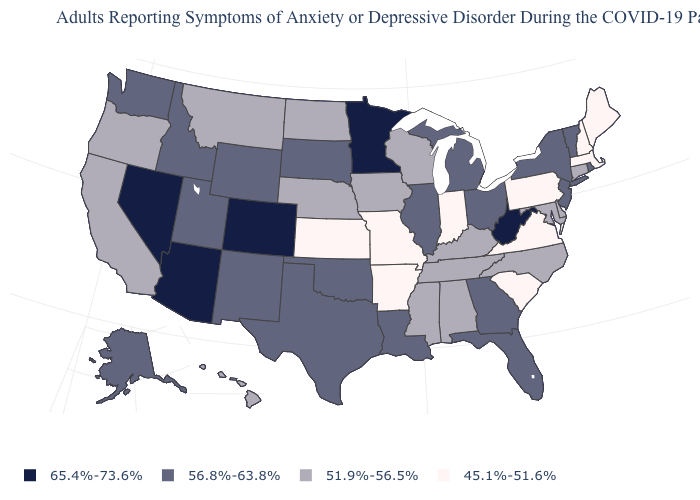Which states hav the highest value in the West?
Give a very brief answer. Arizona, Colorado, Nevada. Name the states that have a value in the range 45.1%-51.6%?
Answer briefly. Arkansas, Indiana, Kansas, Maine, Massachusetts, Missouri, New Hampshire, Pennsylvania, South Carolina, Virginia. Which states have the lowest value in the MidWest?
Be succinct. Indiana, Kansas, Missouri. What is the value of New Jersey?
Short answer required. 56.8%-63.8%. What is the value of Oklahoma?
Quick response, please. 56.8%-63.8%. Among the states that border Connecticut , does Rhode Island have the lowest value?
Concise answer only. No. Does the first symbol in the legend represent the smallest category?
Write a very short answer. No. What is the highest value in states that border Rhode Island?
Short answer required. 51.9%-56.5%. Name the states that have a value in the range 51.9%-56.5%?
Quick response, please. Alabama, California, Connecticut, Delaware, Hawaii, Iowa, Kentucky, Maryland, Mississippi, Montana, Nebraska, North Carolina, North Dakota, Oregon, Tennessee, Wisconsin. Does Idaho have the lowest value in the USA?
Keep it brief. No. Does Colorado have the highest value in the USA?
Concise answer only. Yes. Does Arizona have the highest value in the USA?
Short answer required. Yes. Among the states that border Tennessee , does Georgia have the lowest value?
Answer briefly. No. Does Massachusetts have the highest value in the Northeast?
Write a very short answer. No. Among the states that border Oregon , does Idaho have the highest value?
Be succinct. No. 